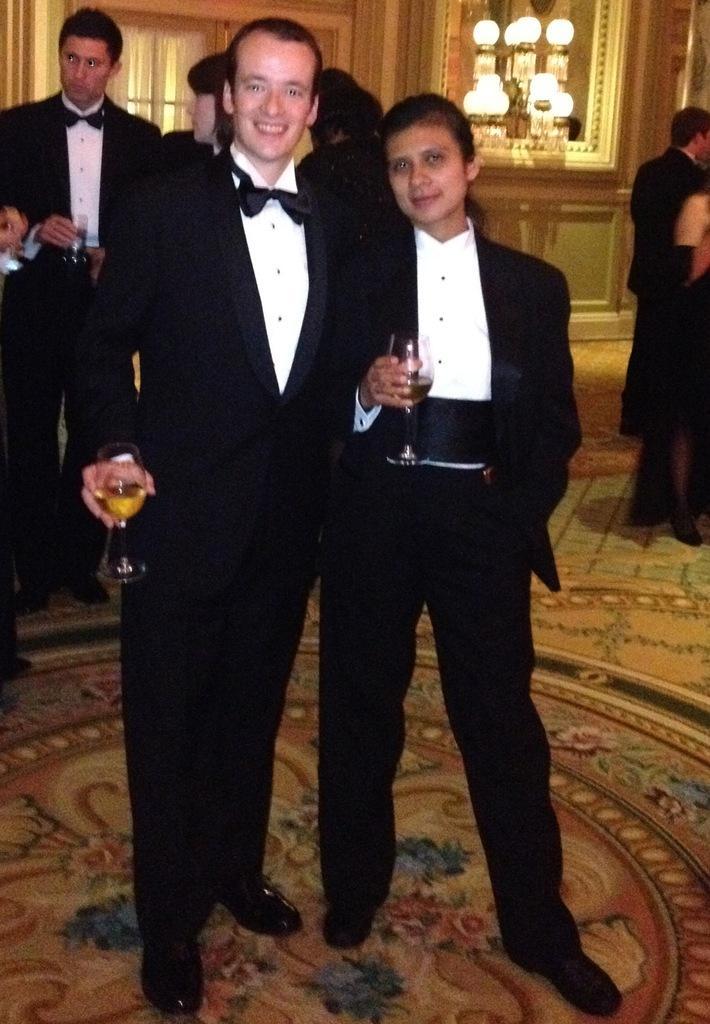Can you describe this image briefly? In this image we can see the people standing and holding the glass of drink. We can also see the wall, a window with the curtain, lights and also the floor. 